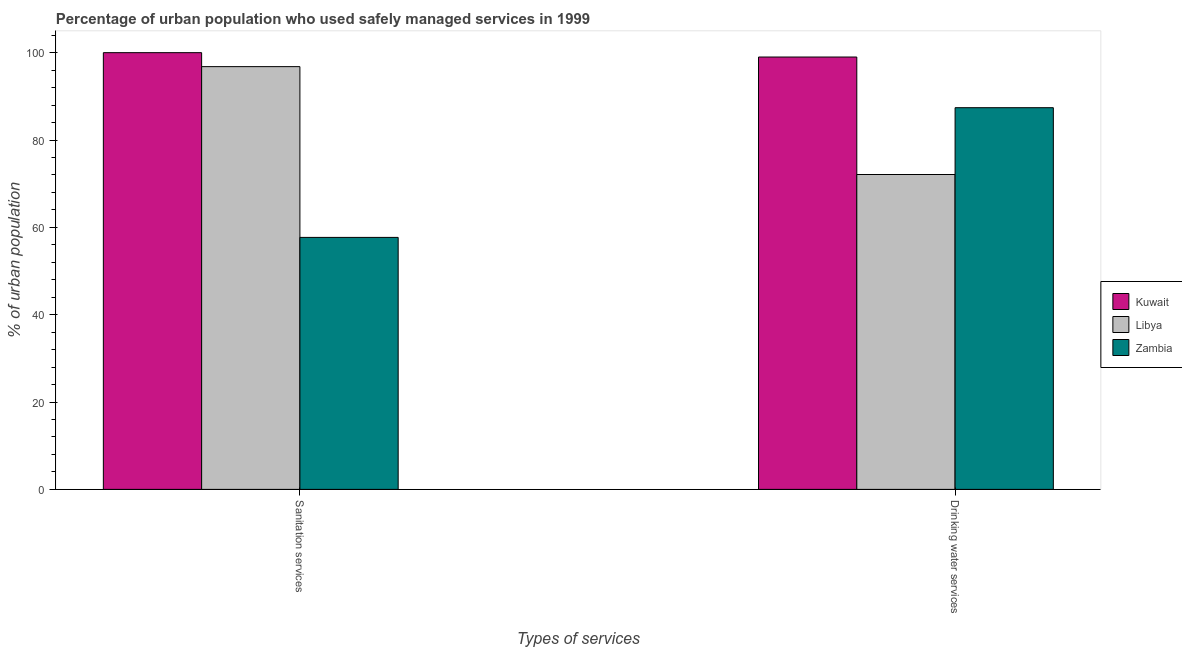How many different coloured bars are there?
Offer a very short reply. 3. How many groups of bars are there?
Give a very brief answer. 2. How many bars are there on the 2nd tick from the left?
Keep it short and to the point. 3. What is the label of the 1st group of bars from the left?
Make the answer very short. Sanitation services. What is the percentage of urban population who used sanitation services in Zambia?
Ensure brevity in your answer.  57.7. Across all countries, what is the maximum percentage of urban population who used drinking water services?
Provide a succinct answer. 99. Across all countries, what is the minimum percentage of urban population who used sanitation services?
Your response must be concise. 57.7. In which country was the percentage of urban population who used drinking water services maximum?
Offer a very short reply. Kuwait. In which country was the percentage of urban population who used drinking water services minimum?
Ensure brevity in your answer.  Libya. What is the total percentage of urban population who used sanitation services in the graph?
Keep it short and to the point. 254.5. What is the difference between the percentage of urban population who used drinking water services in Kuwait and that in Libya?
Offer a very short reply. 26.9. What is the difference between the percentage of urban population who used drinking water services in Zambia and the percentage of urban population who used sanitation services in Libya?
Give a very brief answer. -9.4. What is the average percentage of urban population who used drinking water services per country?
Make the answer very short. 86.17. What is the difference between the percentage of urban population who used sanitation services and percentage of urban population who used drinking water services in Zambia?
Give a very brief answer. -29.7. In how many countries, is the percentage of urban population who used drinking water services greater than 88 %?
Give a very brief answer. 1. What is the ratio of the percentage of urban population who used drinking water services in Zambia to that in Libya?
Provide a succinct answer. 1.21. What does the 1st bar from the left in Drinking water services represents?
Your answer should be compact. Kuwait. What does the 1st bar from the right in Drinking water services represents?
Provide a short and direct response. Zambia. Are all the bars in the graph horizontal?
Keep it short and to the point. No. How many countries are there in the graph?
Your response must be concise. 3. What is the difference between two consecutive major ticks on the Y-axis?
Your answer should be compact. 20. Does the graph contain any zero values?
Your answer should be compact. No. Where does the legend appear in the graph?
Provide a succinct answer. Center right. How many legend labels are there?
Keep it short and to the point. 3. How are the legend labels stacked?
Your answer should be compact. Vertical. What is the title of the graph?
Your answer should be very brief. Percentage of urban population who used safely managed services in 1999. Does "Nepal" appear as one of the legend labels in the graph?
Your answer should be very brief. No. What is the label or title of the X-axis?
Keep it short and to the point. Types of services. What is the label or title of the Y-axis?
Provide a short and direct response. % of urban population. What is the % of urban population in Kuwait in Sanitation services?
Give a very brief answer. 100. What is the % of urban population of Libya in Sanitation services?
Give a very brief answer. 96.8. What is the % of urban population of Zambia in Sanitation services?
Your answer should be compact. 57.7. What is the % of urban population of Libya in Drinking water services?
Keep it short and to the point. 72.1. What is the % of urban population in Zambia in Drinking water services?
Make the answer very short. 87.4. Across all Types of services, what is the maximum % of urban population of Kuwait?
Offer a very short reply. 100. Across all Types of services, what is the maximum % of urban population in Libya?
Your answer should be compact. 96.8. Across all Types of services, what is the maximum % of urban population in Zambia?
Provide a succinct answer. 87.4. Across all Types of services, what is the minimum % of urban population of Libya?
Keep it short and to the point. 72.1. Across all Types of services, what is the minimum % of urban population in Zambia?
Provide a succinct answer. 57.7. What is the total % of urban population of Kuwait in the graph?
Your answer should be very brief. 199. What is the total % of urban population in Libya in the graph?
Offer a terse response. 168.9. What is the total % of urban population of Zambia in the graph?
Provide a succinct answer. 145.1. What is the difference between the % of urban population in Libya in Sanitation services and that in Drinking water services?
Provide a succinct answer. 24.7. What is the difference between the % of urban population of Zambia in Sanitation services and that in Drinking water services?
Offer a very short reply. -29.7. What is the difference between the % of urban population in Kuwait in Sanitation services and the % of urban population in Libya in Drinking water services?
Give a very brief answer. 27.9. What is the difference between the % of urban population of Kuwait in Sanitation services and the % of urban population of Zambia in Drinking water services?
Provide a short and direct response. 12.6. What is the average % of urban population in Kuwait per Types of services?
Your answer should be compact. 99.5. What is the average % of urban population of Libya per Types of services?
Provide a short and direct response. 84.45. What is the average % of urban population of Zambia per Types of services?
Your response must be concise. 72.55. What is the difference between the % of urban population in Kuwait and % of urban population in Zambia in Sanitation services?
Your response must be concise. 42.3. What is the difference between the % of urban population of Libya and % of urban population of Zambia in Sanitation services?
Offer a very short reply. 39.1. What is the difference between the % of urban population of Kuwait and % of urban population of Libya in Drinking water services?
Your response must be concise. 26.9. What is the difference between the % of urban population in Kuwait and % of urban population in Zambia in Drinking water services?
Offer a terse response. 11.6. What is the difference between the % of urban population of Libya and % of urban population of Zambia in Drinking water services?
Provide a short and direct response. -15.3. What is the ratio of the % of urban population of Libya in Sanitation services to that in Drinking water services?
Your answer should be very brief. 1.34. What is the ratio of the % of urban population of Zambia in Sanitation services to that in Drinking water services?
Offer a very short reply. 0.66. What is the difference between the highest and the second highest % of urban population of Libya?
Give a very brief answer. 24.7. What is the difference between the highest and the second highest % of urban population in Zambia?
Keep it short and to the point. 29.7. What is the difference between the highest and the lowest % of urban population of Libya?
Your answer should be very brief. 24.7. What is the difference between the highest and the lowest % of urban population in Zambia?
Provide a succinct answer. 29.7. 